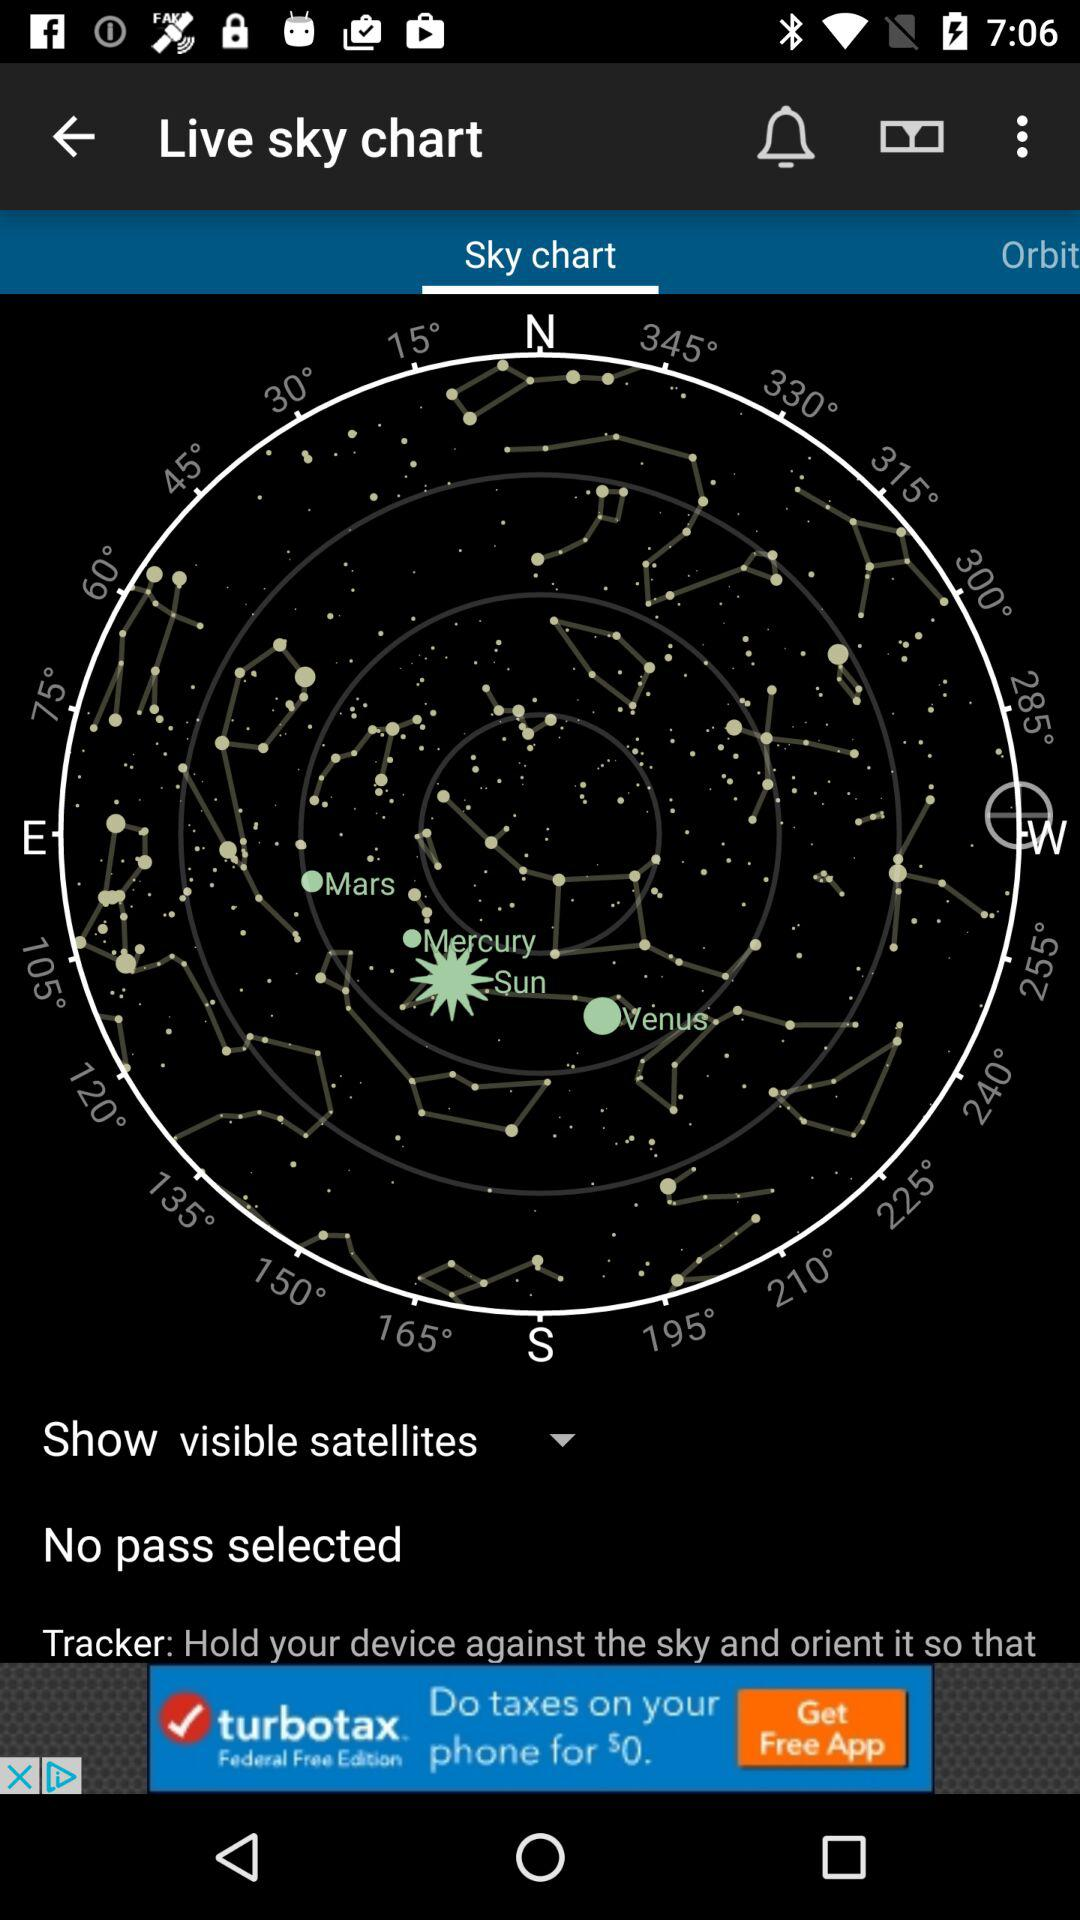Which chart is being shown right now? The shown chart is "Sky chart". 